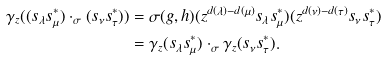<formula> <loc_0><loc_0><loc_500><loc_500>\gamma _ { z } ( ( s _ { \lambda } s _ { \mu } ^ { * } ) \cdot _ { \sigma } ( s _ { \nu } s _ { \tau } ^ { * } ) ) & = \sigma ( g , h ) ( z ^ { d ( \lambda ) - d ( \mu ) } s _ { \lambda } s _ { \mu } ^ { * } ) ( z ^ { d ( \nu ) - d ( \tau ) } s _ { \nu } s _ { \tau } ^ { * } ) \\ & = \gamma _ { z } ( s _ { \lambda } s _ { \mu } ^ { * } ) \cdot _ { \sigma } \gamma _ { z } ( s _ { \nu } s _ { \tau } ^ { * } ) .</formula> 